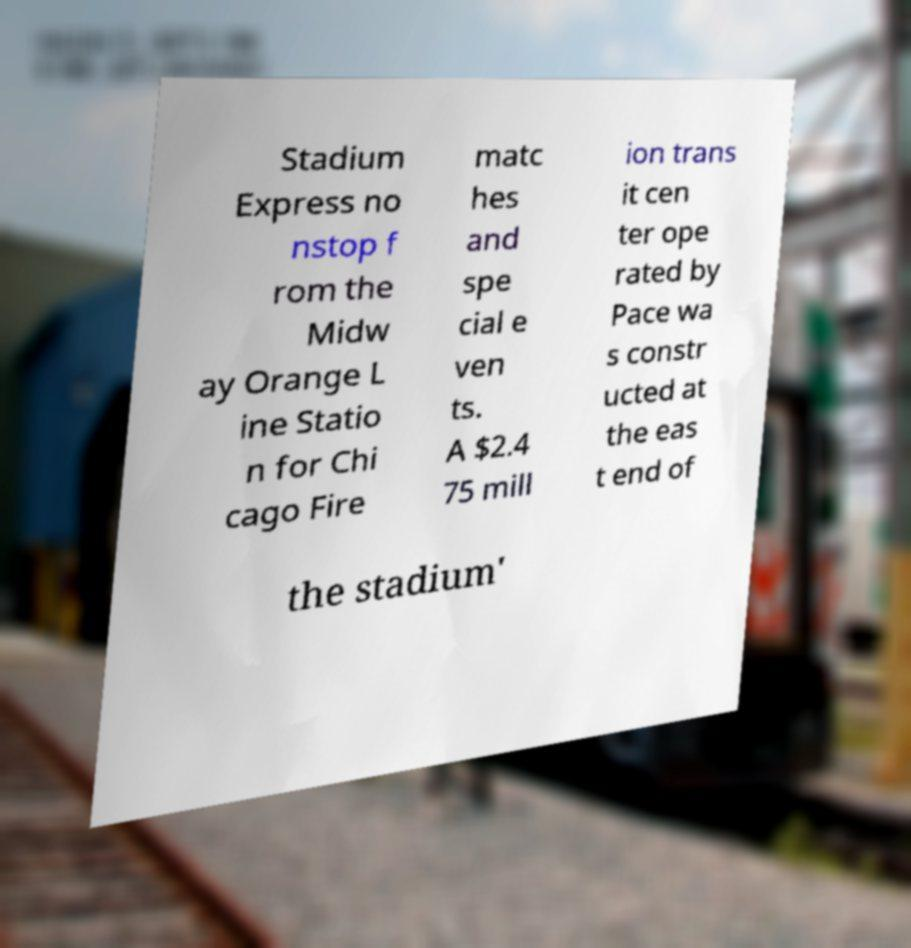What messages or text are displayed in this image? I need them in a readable, typed format. Stadium Express no nstop f rom the Midw ay Orange L ine Statio n for Chi cago Fire matc hes and spe cial e ven ts. A $2.4 75 mill ion trans it cen ter ope rated by Pace wa s constr ucted at the eas t end of the stadium' 